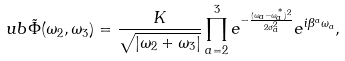Convert formula to latex. <formula><loc_0><loc_0><loc_500><loc_500>\ u b { \tilde { \Phi } } ( \omega _ { 2 } , \omega _ { 3 } ) = \frac { K } { \sqrt { | \omega _ { 2 } + \omega _ { 3 } | } } \prod _ { a = 2 } ^ { 3 } e ^ { - \frac { ( \omega _ { a } - \omega _ { a } ^ { ^ { * } } ) ^ { 2 } } { 2 \sigma _ { a } ^ { 2 } } } e ^ { i \beta ^ { a } \omega _ { a } } ,</formula> 